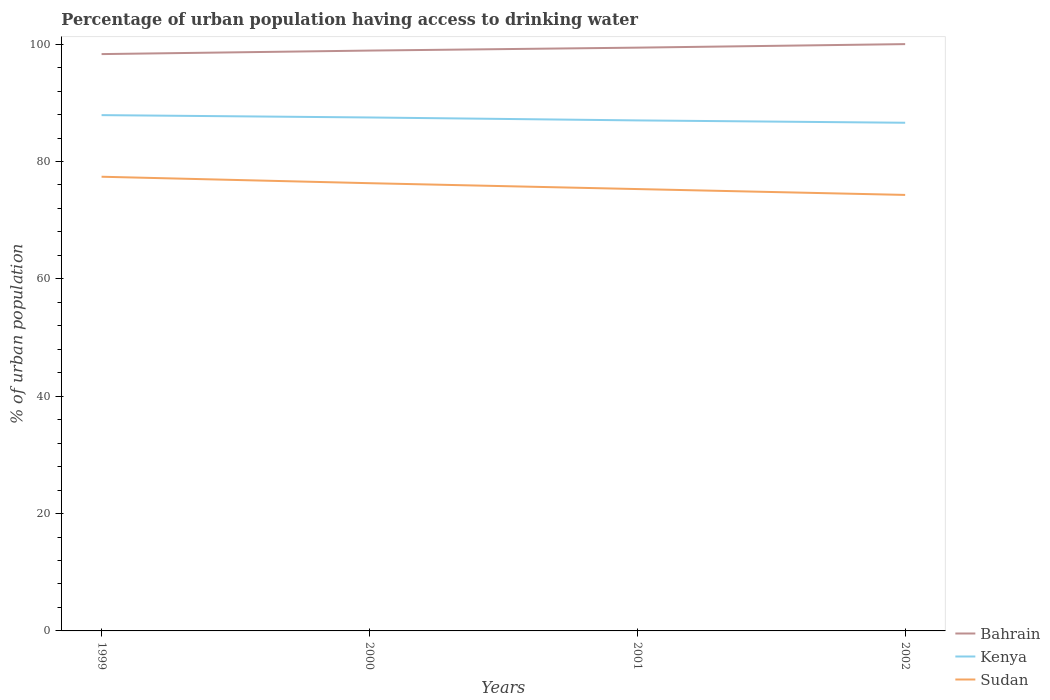Across all years, what is the maximum percentage of urban population having access to drinking water in Kenya?
Your answer should be very brief. 86.6. In which year was the percentage of urban population having access to drinking water in Sudan maximum?
Provide a succinct answer. 2002. What is the total percentage of urban population having access to drinking water in Sudan in the graph?
Your answer should be compact. 1. What is the difference between the highest and the second highest percentage of urban population having access to drinking water in Kenya?
Offer a very short reply. 1.3. What is the difference between the highest and the lowest percentage of urban population having access to drinking water in Sudan?
Offer a very short reply. 2. Is the percentage of urban population having access to drinking water in Sudan strictly greater than the percentage of urban population having access to drinking water in Kenya over the years?
Provide a succinct answer. Yes. How many lines are there?
Your answer should be compact. 3. Does the graph contain grids?
Ensure brevity in your answer.  No. Where does the legend appear in the graph?
Offer a very short reply. Bottom right. How many legend labels are there?
Keep it short and to the point. 3. What is the title of the graph?
Your answer should be very brief. Percentage of urban population having access to drinking water. What is the label or title of the Y-axis?
Your answer should be compact. % of urban population. What is the % of urban population in Bahrain in 1999?
Keep it short and to the point. 98.3. What is the % of urban population in Kenya in 1999?
Give a very brief answer. 87.9. What is the % of urban population of Sudan in 1999?
Give a very brief answer. 77.4. What is the % of urban population of Bahrain in 2000?
Provide a succinct answer. 98.9. What is the % of urban population of Kenya in 2000?
Ensure brevity in your answer.  87.5. What is the % of urban population of Sudan in 2000?
Provide a succinct answer. 76.3. What is the % of urban population of Bahrain in 2001?
Your answer should be compact. 99.4. What is the % of urban population of Kenya in 2001?
Provide a short and direct response. 87. What is the % of urban population in Sudan in 2001?
Give a very brief answer. 75.3. What is the % of urban population in Kenya in 2002?
Your response must be concise. 86.6. What is the % of urban population in Sudan in 2002?
Your response must be concise. 74.3. Across all years, what is the maximum % of urban population of Bahrain?
Keep it short and to the point. 100. Across all years, what is the maximum % of urban population of Kenya?
Give a very brief answer. 87.9. Across all years, what is the maximum % of urban population of Sudan?
Ensure brevity in your answer.  77.4. Across all years, what is the minimum % of urban population of Bahrain?
Ensure brevity in your answer.  98.3. Across all years, what is the minimum % of urban population of Kenya?
Your answer should be very brief. 86.6. Across all years, what is the minimum % of urban population of Sudan?
Make the answer very short. 74.3. What is the total % of urban population in Bahrain in the graph?
Provide a succinct answer. 396.6. What is the total % of urban population in Kenya in the graph?
Provide a short and direct response. 349. What is the total % of urban population of Sudan in the graph?
Your response must be concise. 303.3. What is the difference between the % of urban population in Bahrain in 1999 and that in 2000?
Your answer should be very brief. -0.6. What is the difference between the % of urban population in Kenya in 1999 and that in 2000?
Make the answer very short. 0.4. What is the difference between the % of urban population of Sudan in 1999 and that in 2000?
Your response must be concise. 1.1. What is the difference between the % of urban population in Bahrain in 1999 and that in 2002?
Offer a terse response. -1.7. What is the difference between the % of urban population in Kenya in 1999 and that in 2002?
Ensure brevity in your answer.  1.3. What is the difference between the % of urban population of Bahrain in 2000 and that in 2001?
Your answer should be very brief. -0.5. What is the difference between the % of urban population of Kenya in 2000 and that in 2001?
Offer a terse response. 0.5. What is the difference between the % of urban population of Sudan in 2000 and that in 2002?
Offer a terse response. 2. What is the difference between the % of urban population in Bahrain in 2001 and that in 2002?
Make the answer very short. -0.6. What is the difference between the % of urban population in Sudan in 2001 and that in 2002?
Make the answer very short. 1. What is the difference between the % of urban population of Bahrain in 1999 and the % of urban population of Kenya in 2000?
Provide a short and direct response. 10.8. What is the difference between the % of urban population in Bahrain in 1999 and the % of urban population in Sudan in 2000?
Offer a terse response. 22. What is the difference between the % of urban population of Kenya in 1999 and the % of urban population of Sudan in 2000?
Ensure brevity in your answer.  11.6. What is the difference between the % of urban population in Bahrain in 1999 and the % of urban population in Kenya in 2001?
Make the answer very short. 11.3. What is the difference between the % of urban population of Kenya in 1999 and the % of urban population of Sudan in 2001?
Offer a terse response. 12.6. What is the difference between the % of urban population of Bahrain in 2000 and the % of urban population of Sudan in 2001?
Provide a succinct answer. 23.6. What is the difference between the % of urban population in Kenya in 2000 and the % of urban population in Sudan in 2001?
Provide a short and direct response. 12.2. What is the difference between the % of urban population of Bahrain in 2000 and the % of urban population of Kenya in 2002?
Your answer should be compact. 12.3. What is the difference between the % of urban population of Bahrain in 2000 and the % of urban population of Sudan in 2002?
Provide a short and direct response. 24.6. What is the difference between the % of urban population in Kenya in 2000 and the % of urban population in Sudan in 2002?
Make the answer very short. 13.2. What is the difference between the % of urban population of Bahrain in 2001 and the % of urban population of Sudan in 2002?
Ensure brevity in your answer.  25.1. What is the difference between the % of urban population of Kenya in 2001 and the % of urban population of Sudan in 2002?
Make the answer very short. 12.7. What is the average % of urban population in Bahrain per year?
Your answer should be very brief. 99.15. What is the average % of urban population of Kenya per year?
Give a very brief answer. 87.25. What is the average % of urban population in Sudan per year?
Your answer should be very brief. 75.83. In the year 1999, what is the difference between the % of urban population of Bahrain and % of urban population of Sudan?
Ensure brevity in your answer.  20.9. In the year 1999, what is the difference between the % of urban population in Kenya and % of urban population in Sudan?
Ensure brevity in your answer.  10.5. In the year 2000, what is the difference between the % of urban population in Bahrain and % of urban population in Kenya?
Provide a short and direct response. 11.4. In the year 2000, what is the difference between the % of urban population of Bahrain and % of urban population of Sudan?
Your answer should be very brief. 22.6. In the year 2000, what is the difference between the % of urban population of Kenya and % of urban population of Sudan?
Make the answer very short. 11.2. In the year 2001, what is the difference between the % of urban population in Bahrain and % of urban population in Sudan?
Your answer should be compact. 24.1. In the year 2001, what is the difference between the % of urban population of Kenya and % of urban population of Sudan?
Ensure brevity in your answer.  11.7. In the year 2002, what is the difference between the % of urban population of Bahrain and % of urban population of Kenya?
Give a very brief answer. 13.4. In the year 2002, what is the difference between the % of urban population of Bahrain and % of urban population of Sudan?
Your answer should be compact. 25.7. What is the ratio of the % of urban population in Kenya in 1999 to that in 2000?
Give a very brief answer. 1. What is the ratio of the % of urban population of Sudan in 1999 to that in 2000?
Keep it short and to the point. 1.01. What is the ratio of the % of urban population of Bahrain in 1999 to that in 2001?
Make the answer very short. 0.99. What is the ratio of the % of urban population in Kenya in 1999 to that in 2001?
Provide a short and direct response. 1.01. What is the ratio of the % of urban population in Sudan in 1999 to that in 2001?
Keep it short and to the point. 1.03. What is the ratio of the % of urban population in Bahrain in 1999 to that in 2002?
Give a very brief answer. 0.98. What is the ratio of the % of urban population in Sudan in 1999 to that in 2002?
Provide a short and direct response. 1.04. What is the ratio of the % of urban population of Bahrain in 2000 to that in 2001?
Your answer should be very brief. 0.99. What is the ratio of the % of urban population in Kenya in 2000 to that in 2001?
Your answer should be compact. 1.01. What is the ratio of the % of urban population in Sudan in 2000 to that in 2001?
Your answer should be very brief. 1.01. What is the ratio of the % of urban population in Kenya in 2000 to that in 2002?
Your response must be concise. 1.01. What is the ratio of the % of urban population in Sudan in 2000 to that in 2002?
Ensure brevity in your answer.  1.03. What is the ratio of the % of urban population of Bahrain in 2001 to that in 2002?
Keep it short and to the point. 0.99. What is the ratio of the % of urban population of Kenya in 2001 to that in 2002?
Keep it short and to the point. 1. What is the ratio of the % of urban population in Sudan in 2001 to that in 2002?
Provide a short and direct response. 1.01. What is the difference between the highest and the second highest % of urban population in Bahrain?
Make the answer very short. 0.6. 